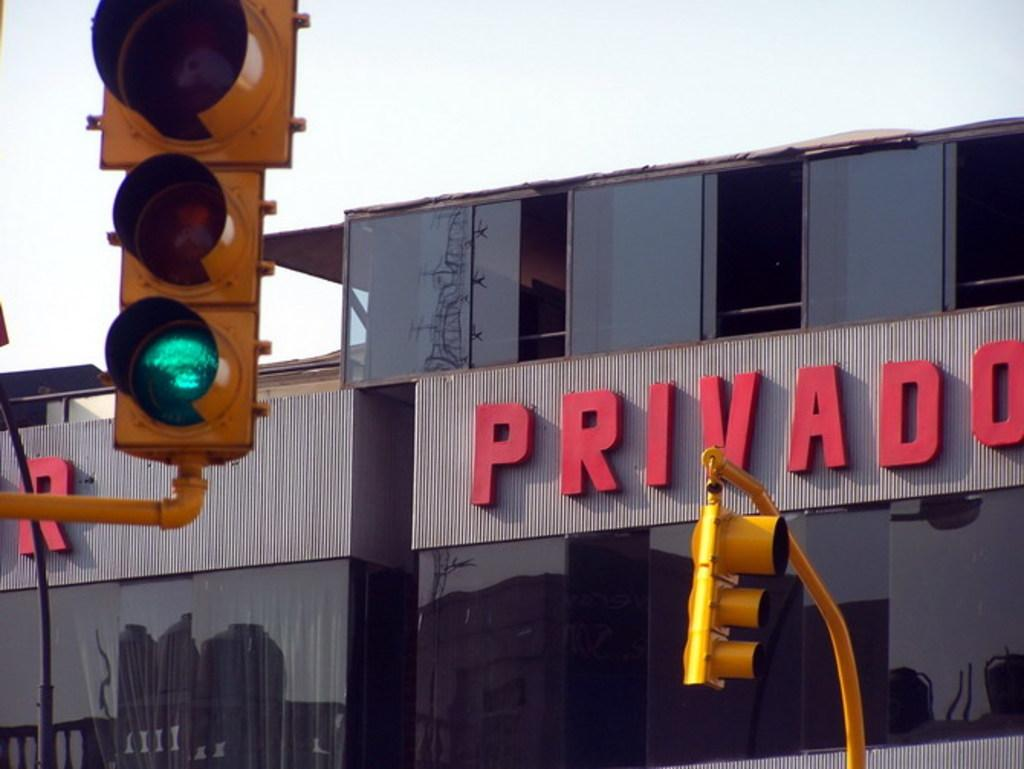<image>
Describe the image concisely. A building for Privado is seen behind some traffic lights. 